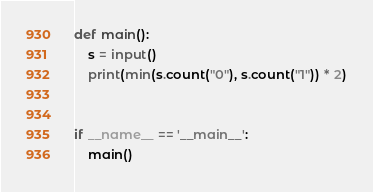Convert code to text. <code><loc_0><loc_0><loc_500><loc_500><_Python_>def main():
    s = input()
    print(min(s.count("0"), s.count("1")) * 2)


if __name__ == '__main__':
    main()

</code> 